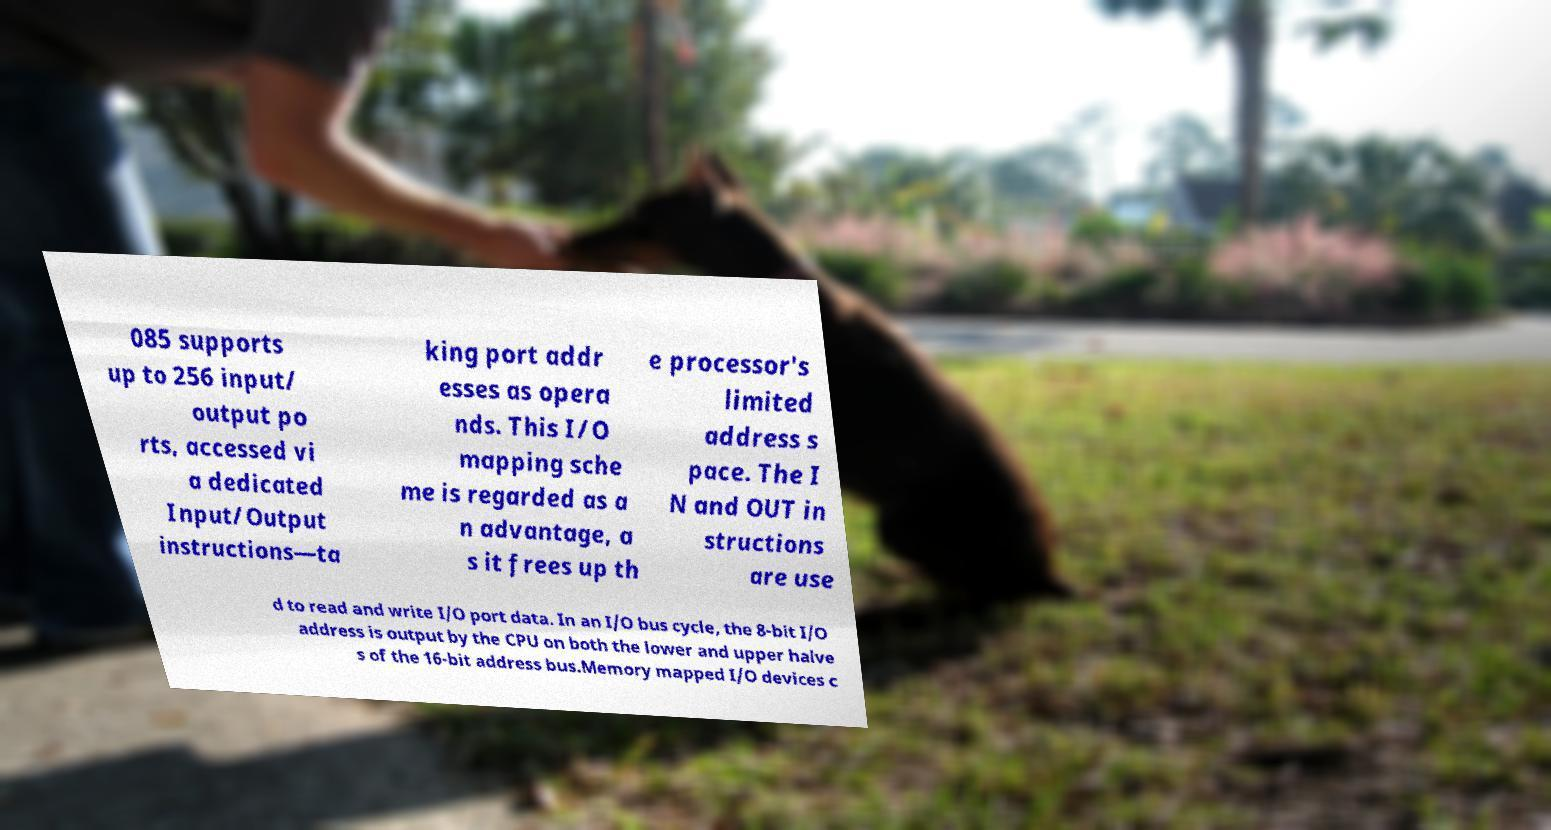For documentation purposes, I need the text within this image transcribed. Could you provide that? 085 supports up to 256 input/ output po rts, accessed vi a dedicated Input/Output instructions—ta king port addr esses as opera nds. This I/O mapping sche me is regarded as a n advantage, a s it frees up th e processor's limited address s pace. The I N and OUT in structions are use d to read and write I/O port data. In an I/O bus cycle, the 8-bit I/O address is output by the CPU on both the lower and upper halve s of the 16-bit address bus.Memory mapped I/O devices c 